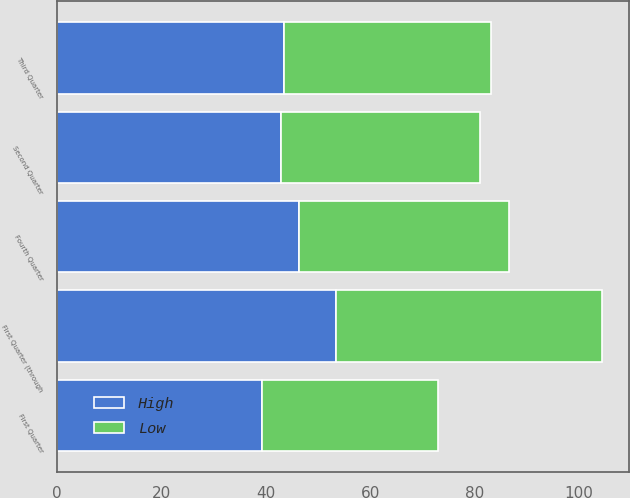Convert chart. <chart><loc_0><loc_0><loc_500><loc_500><stacked_bar_chart><ecel><fcel>First Quarter<fcel>Second Quarter<fcel>Third Quarter<fcel>Fourth Quarter<fcel>First Quarter (through<nl><fcel>High<fcel>39.26<fcel>42.99<fcel>43.58<fcel>46.37<fcel>53.49<nl><fcel>Low<fcel>33.7<fcel>37.97<fcel>39.6<fcel>40.29<fcel>50.82<nl></chart> 